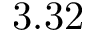<formula> <loc_0><loc_0><loc_500><loc_500>3 . 3 2</formula> 